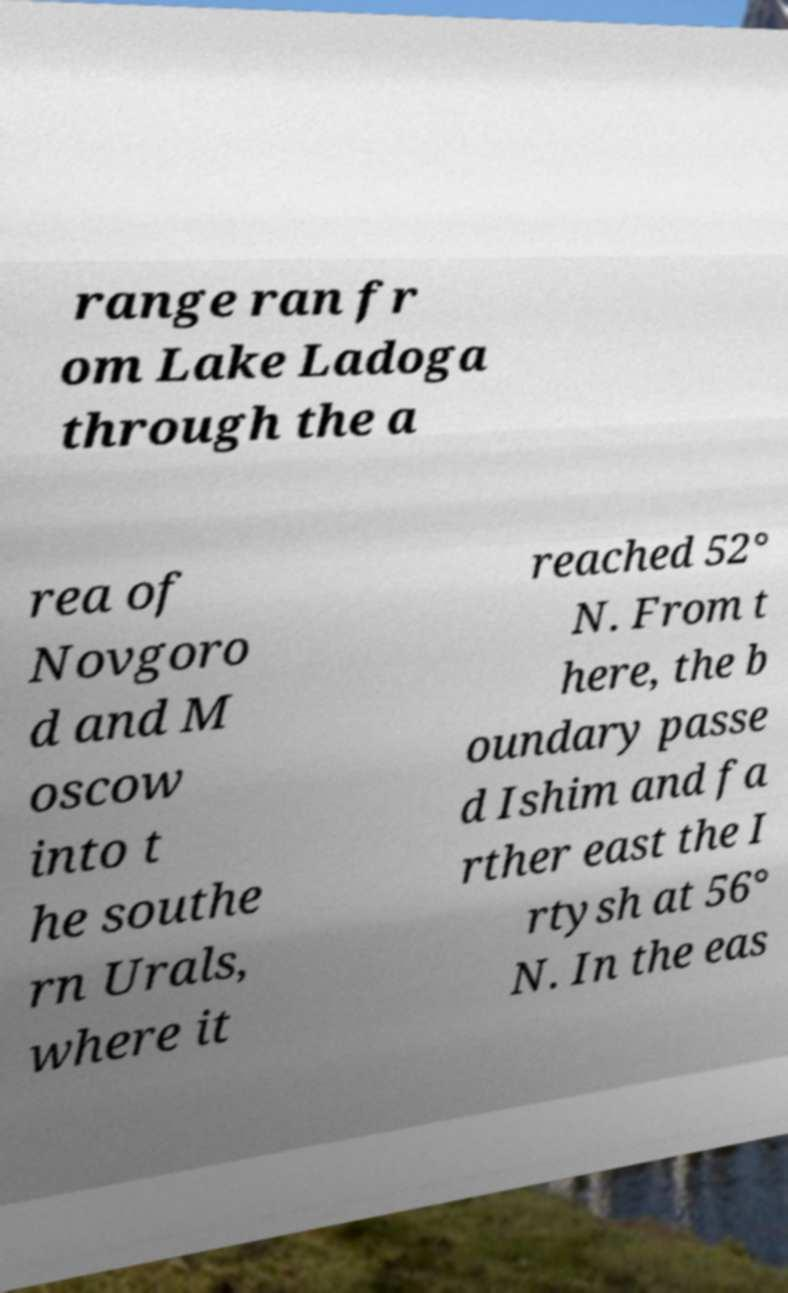What messages or text are displayed in this image? I need them in a readable, typed format. range ran fr om Lake Ladoga through the a rea of Novgoro d and M oscow into t he southe rn Urals, where it reached 52° N. From t here, the b oundary passe d Ishim and fa rther east the I rtysh at 56° N. In the eas 